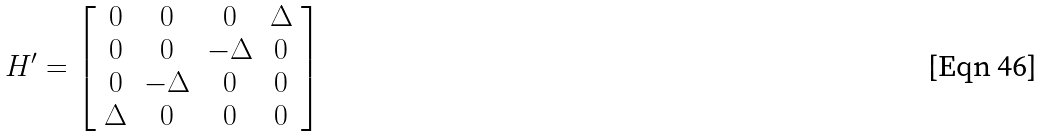<formula> <loc_0><loc_0><loc_500><loc_500>H ^ { \prime } = \left [ \begin{array} { c c c c } 0 & 0 & 0 & \Delta \\ 0 & 0 & - \Delta & 0 \\ 0 & - \Delta & 0 & 0 \\ \Delta & 0 & 0 & 0 \end{array} \right ]</formula> 